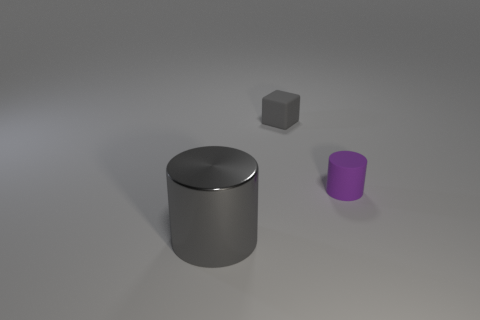There is a rubber cylinder; is it the same color as the thing to the left of the gray matte object?
Provide a short and direct response. No. There is a thing that is behind the large cylinder and in front of the rubber cube; what is its color?
Your answer should be very brief. Purple. What number of tiny objects are to the right of the tiny matte thing that is right of the block?
Your answer should be compact. 0. Are there any other big gray metallic things of the same shape as the big gray metallic thing?
Ensure brevity in your answer.  No. Does the gray thing that is to the right of the metallic cylinder have the same shape as the thing in front of the tiny cylinder?
Offer a terse response. No. What number of objects are big green shiny cubes or tiny matte things?
Your answer should be compact. 2. What is the size of the gray metallic object that is the same shape as the purple rubber thing?
Your answer should be very brief. Large. Is the number of gray objects that are behind the small purple matte cylinder greater than the number of large red balls?
Your response must be concise. Yes. Does the gray block have the same material as the big cylinder?
Give a very brief answer. No. What number of objects are purple cylinders that are right of the large gray object or objects that are behind the big cylinder?
Offer a very short reply. 2. 